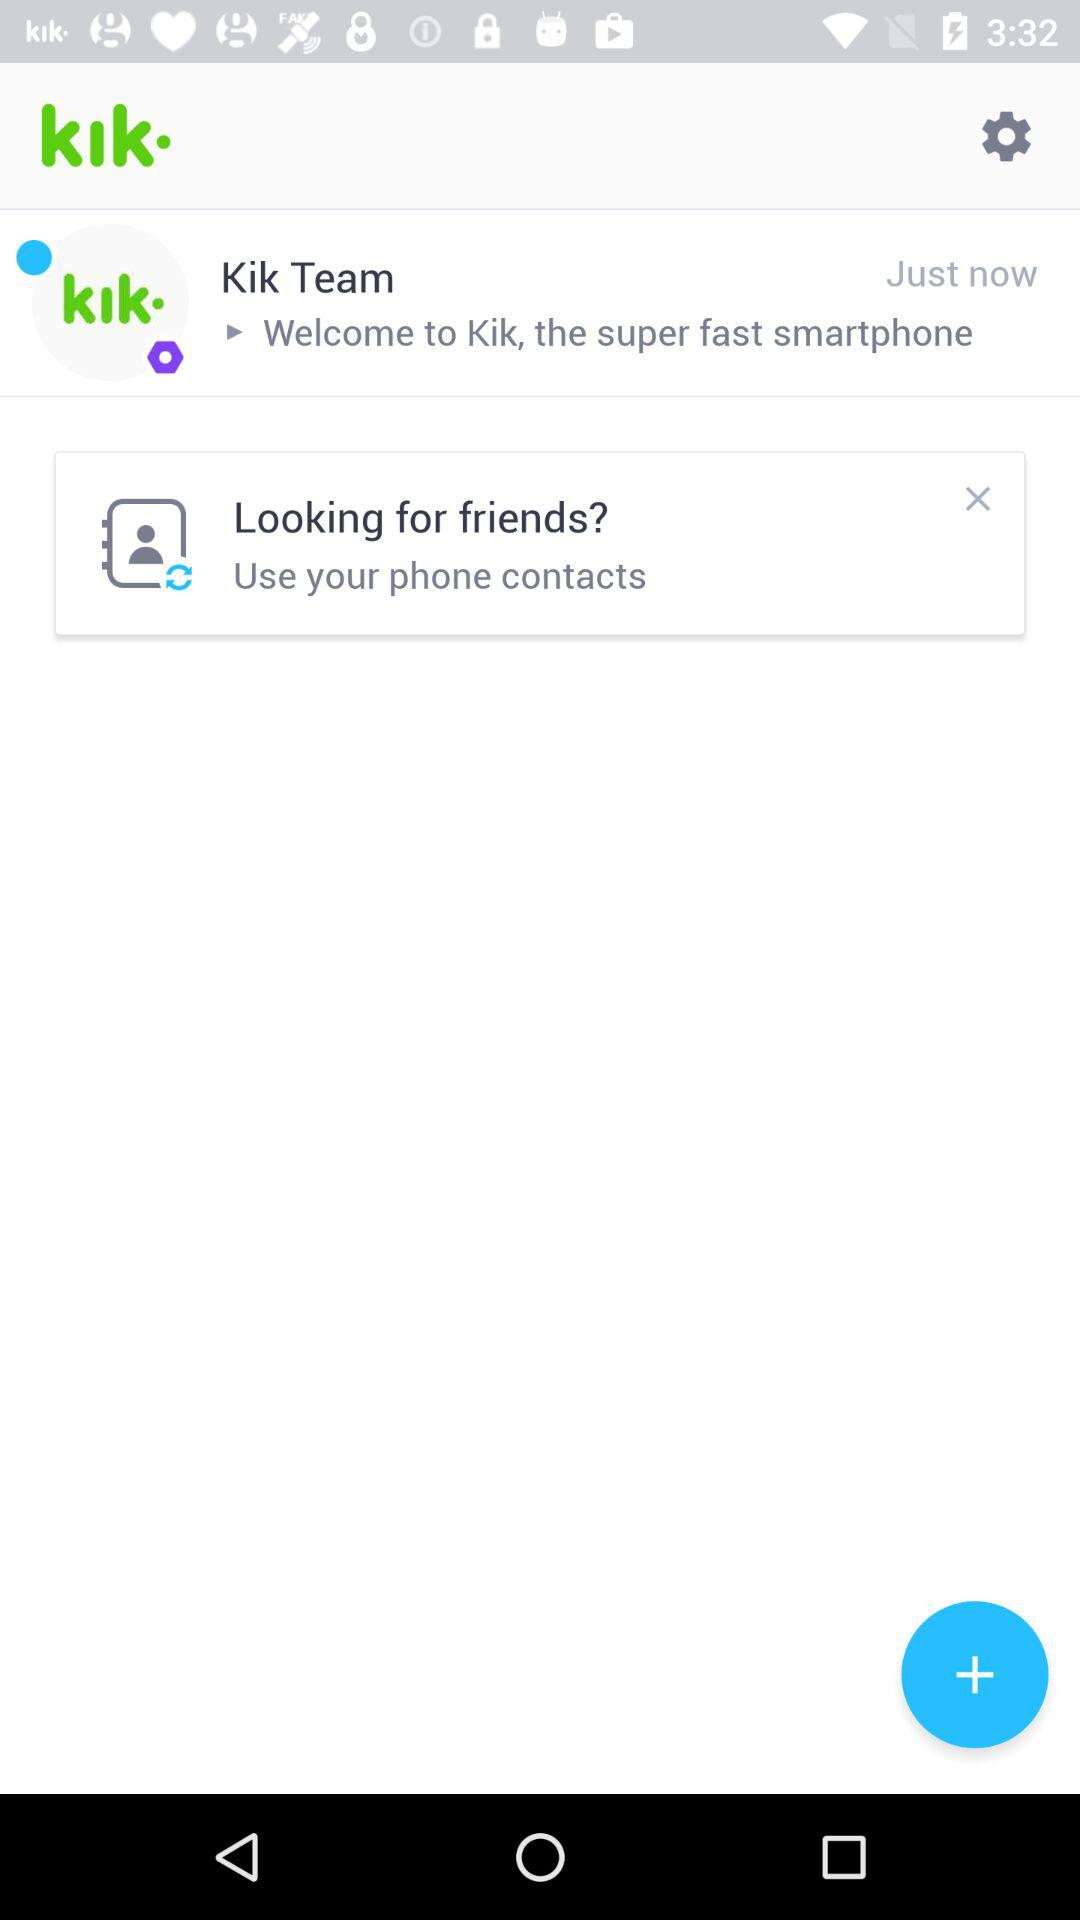When did the message come from the "Kik" team? The message came just now. 